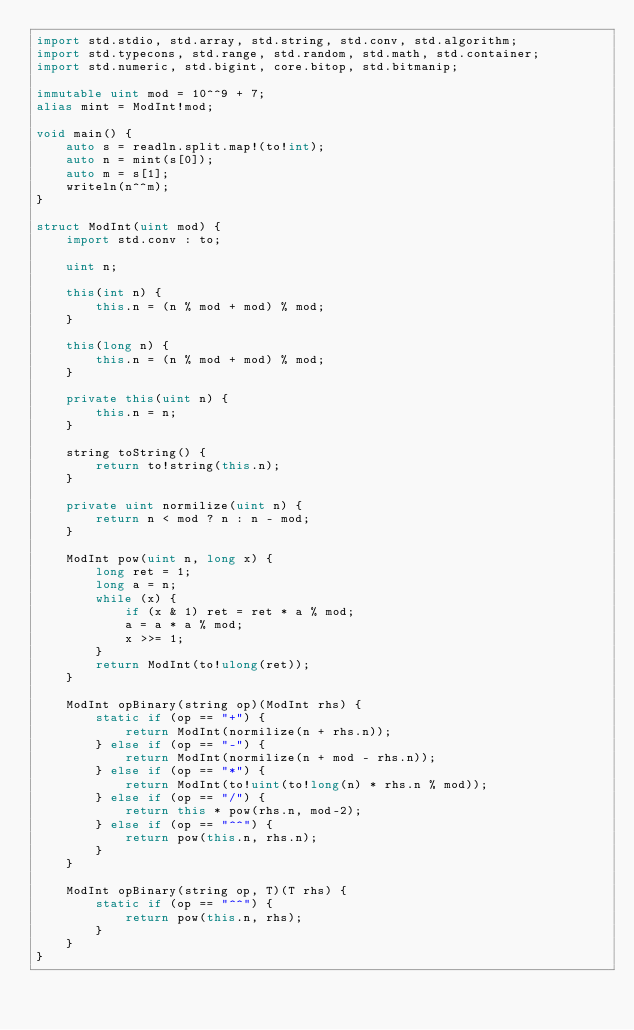<code> <loc_0><loc_0><loc_500><loc_500><_D_>import std.stdio, std.array, std.string, std.conv, std.algorithm;
import std.typecons, std.range, std.random, std.math, std.container;
import std.numeric, std.bigint, core.bitop, std.bitmanip;

immutable uint mod = 10^^9 + 7;
alias mint = ModInt!mod;

void main() {
    auto s = readln.split.map!(to!int);
    auto n = mint(s[0]);
    auto m = s[1];
    writeln(n^^m);
}

struct ModInt(uint mod) {
    import std.conv : to;

    uint n;

    this(int n) {
        this.n = (n % mod + mod) % mod;
    }

    this(long n) {
        this.n = (n % mod + mod) % mod;
    }

    private this(uint n) {
        this.n = n;
    }

    string toString() {
        return to!string(this.n);
    }

    private uint normilize(uint n) {
        return n < mod ? n : n - mod;
    }

    ModInt pow(uint n, long x) {
        long ret = 1;
        long a = n;
        while (x) {
            if (x & 1) ret = ret * a % mod;
            a = a * a % mod;
            x >>= 1;
        }
        return ModInt(to!ulong(ret));
    }

    ModInt opBinary(string op)(ModInt rhs) {
        static if (op == "+") {
            return ModInt(normilize(n + rhs.n));
        } else if (op == "-") {
            return ModInt(normilize(n + mod - rhs.n));
        } else if (op == "*") {
            return ModInt(to!uint(to!long(n) * rhs.n % mod));
        } else if (op == "/") {
            return this * pow(rhs.n, mod-2);
        } else if (op == "^^") {
            return pow(this.n, rhs.n);
        }
    }

    ModInt opBinary(string op, T)(T rhs) {
        static if (op == "^^") {
            return pow(this.n, rhs);
        }
    }
}

</code> 